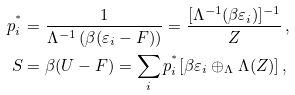Convert formula to latex. <formula><loc_0><loc_0><loc_500><loc_500>p ^ { ^ { * } } _ { i } & = \frac { 1 } { \Lambda ^ { - 1 } \left ( \beta ( \varepsilon _ { i } - F ) \right ) } = \frac { [ \Lambda ^ { - 1 } ( \beta \varepsilon _ { i } ) ] ^ { - 1 } } { Z } \, , \\ S & = \beta ( U - F ) = \sum _ { i } p ^ { ^ { * } } _ { i } [ \beta \varepsilon _ { i } \oplus _ { \Lambda } \Lambda ( Z ) ] \, ,</formula> 